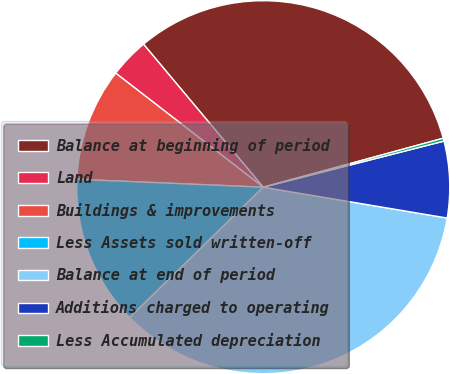Convert chart. <chart><loc_0><loc_0><loc_500><loc_500><pie_chart><fcel>Balance at beginning of period<fcel>Land<fcel>Buildings & improvements<fcel>Less Assets sold written-off<fcel>Balance at end of period<fcel>Additions charged to operating<fcel>Less Accumulated depreciation<nl><fcel>31.87%<fcel>3.43%<fcel>9.8%<fcel>12.98%<fcel>35.05%<fcel>6.62%<fcel>0.25%<nl></chart> 